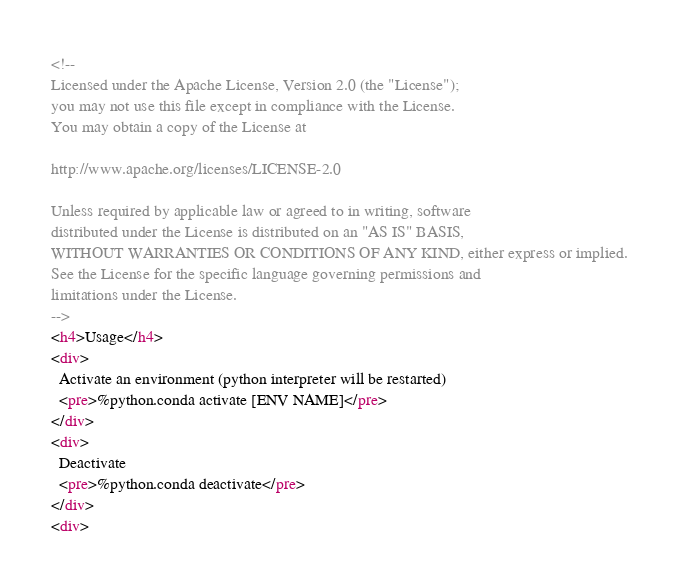<code> <loc_0><loc_0><loc_500><loc_500><_HTML_><!--
Licensed under the Apache License, Version 2.0 (the "License");
you may not use this file except in compliance with the License.
You may obtain a copy of the License at

http://www.apache.org/licenses/LICENSE-2.0

Unless required by applicable law or agreed to in writing, software
distributed under the License is distributed on an "AS IS" BASIS,
WITHOUT WARRANTIES OR CONDITIONS OF ANY KIND, either express or implied.
See the License for the specific language governing permissions and
limitations under the License.
-->
<h4>Usage</h4>
<div>
  Activate an environment (python interpreter will be restarted)
  <pre>%python.conda activate [ENV NAME]</pre>
</div>
<div>
  Deactivate
  <pre>%python.conda deactivate</pre>
</div>
<div></code> 